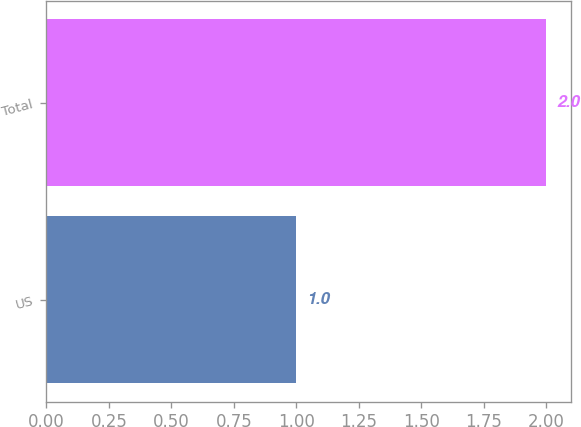Convert chart. <chart><loc_0><loc_0><loc_500><loc_500><bar_chart><fcel>US<fcel>Total<nl><fcel>1<fcel>2<nl></chart> 